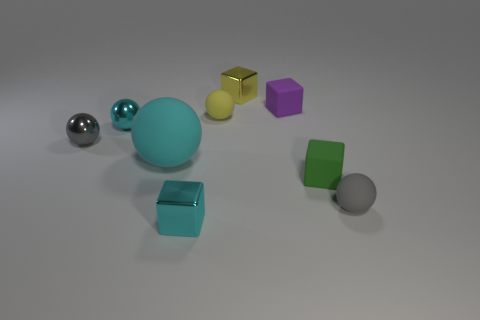How many yellow matte spheres are the same size as the cyan rubber ball?
Provide a short and direct response. 0. The tiny gray thing on the right side of the gray sphere to the left of the metallic cube that is in front of the tiny yellow shiny object is what shape?
Give a very brief answer. Sphere. The small matte sphere behind the small gray rubber ball is what color?
Ensure brevity in your answer.  Yellow. How many objects are tiny metal blocks behind the green block or tiny balls right of the big cyan thing?
Your answer should be very brief. 3. How many other small metallic objects have the same shape as the purple object?
Give a very brief answer. 2. There is another matte ball that is the same size as the yellow matte ball; what color is it?
Your answer should be very brief. Gray. The shiny sphere that is in front of the cyan object that is behind the small gray ball on the left side of the small yellow cube is what color?
Your response must be concise. Gray. There is a green matte cube; is its size the same as the block on the left side of the yellow block?
Give a very brief answer. Yes. How many things are either tiny matte objects or large yellow matte cylinders?
Offer a very short reply. 4. Are there any cyan cubes that have the same material as the small yellow cube?
Your response must be concise. Yes. 